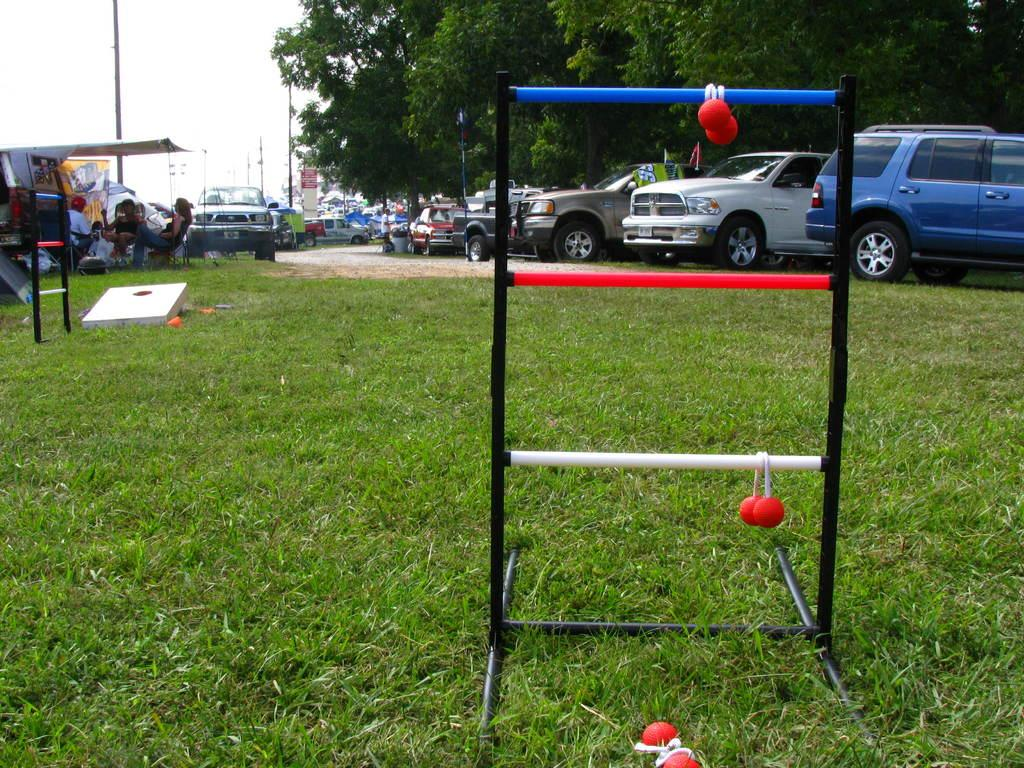What is hanging from the stand in the image? There are balls hanging from a stand in the image. What type of vehicles are in the image? There are cars in the image. Who or what is present in the image besides the cars? There are people and poles in the image. What type of natural vegetation is visible in the image? There are trees in the image. What religion is being practiced by the people in the image? There is no indication of any religious practice in the image. What is the tendency of the rod in the image? There is no rod present in the image. 